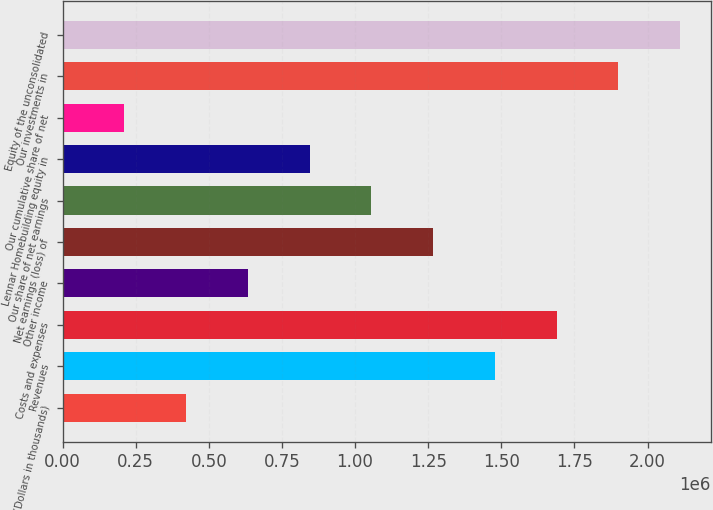Convert chart. <chart><loc_0><loc_0><loc_500><loc_500><bar_chart><fcel>(Dollars in thousands)<fcel>Revenues<fcel>Costs and expenses<fcel>Other income<fcel>Net earnings (loss) of<fcel>Our share of net earnings<fcel>Lennar Homebuilding equity in<fcel>Our cumulative share of net<fcel>Our investments in<fcel>Equity of the unconsolidated<nl><fcel>422256<fcel>1.47783e+06<fcel>1.68894e+06<fcel>633371<fcel>1.26671e+06<fcel>1.0556e+06<fcel>844485<fcel>211142<fcel>1.90006e+06<fcel>2.11117e+06<nl></chart> 